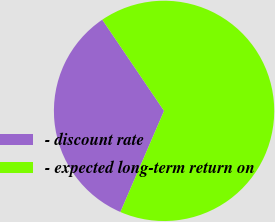Convert chart to OTSL. <chart><loc_0><loc_0><loc_500><loc_500><pie_chart><fcel>- discount rate<fcel>- expected long-term return on<nl><fcel>34.04%<fcel>65.96%<nl></chart> 